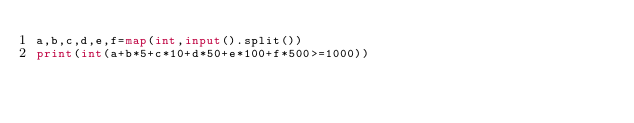Convert code to text. <code><loc_0><loc_0><loc_500><loc_500><_Python_>a,b,c,d,e,f=map(int,input().split())
print(int(a+b*5+c*10+d*50+e*100+f*500>=1000))</code> 